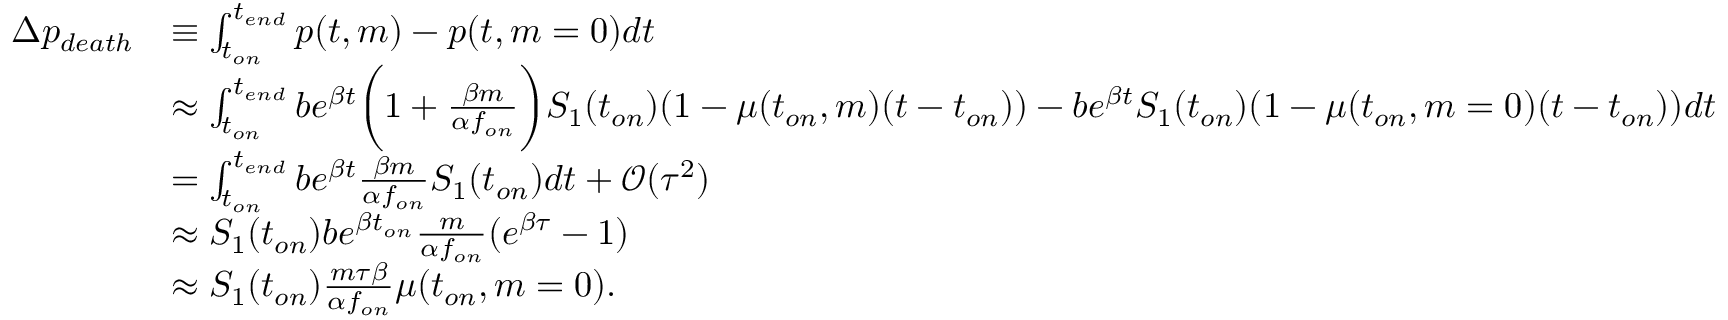Convert formula to latex. <formula><loc_0><loc_0><loc_500><loc_500>\begin{array} { r l } { \Delta p _ { d e a t h } } & { \equiv \int _ { t _ { o n } } ^ { t _ { e n d } } p ( t , m ) - p ( t , m = 0 ) d t } \\ & { \approx \int _ { t _ { o n } } ^ { t _ { e n d } } b e ^ { \beta t } \left ( 1 + \frac { \beta m } { \alpha f _ { o n } } \right ) S _ { 1 } ( t _ { o n } ) ( 1 - \mu ( t _ { o n } , m ) ( t - t _ { o n } ) ) - b e ^ { \beta t } S _ { 1 } ( t _ { o n } ) ( 1 - \mu ( t _ { o n } , m = 0 ) ( t - t _ { o n } ) ) d t } \\ & { = \int _ { t _ { o n } } ^ { t _ { e n d } } b e ^ { \beta t } \frac { \beta m } { \alpha f _ { o n } } S _ { 1 } ( t _ { o n } ) d t + \mathcal { O } ( \tau ^ { 2 } ) } \\ & { \approx S _ { 1 } ( t _ { o n } ) b e ^ { \beta t _ { o n } } \frac { m } { \alpha f _ { o n } } ( e ^ { \beta \tau } - 1 ) } \\ & { \approx S _ { 1 } ( t _ { o n } ) \frac { m \tau \beta } { \alpha f _ { o n } } \mu ( t _ { o n } , m = 0 ) . } \end{array}</formula> 